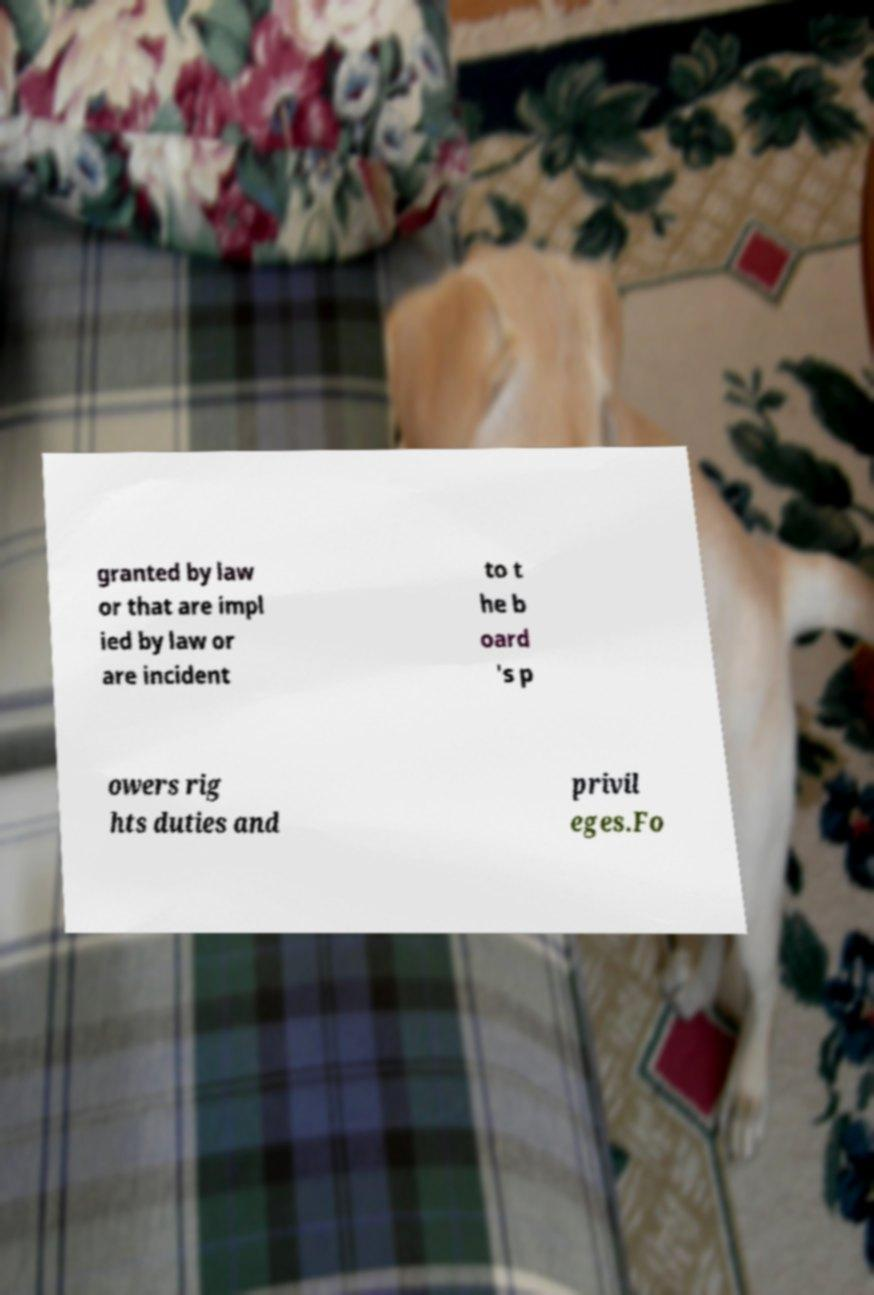Could you extract and type out the text from this image? granted by law or that are impl ied by law or are incident to t he b oard 's p owers rig hts duties and privil eges.Fo 